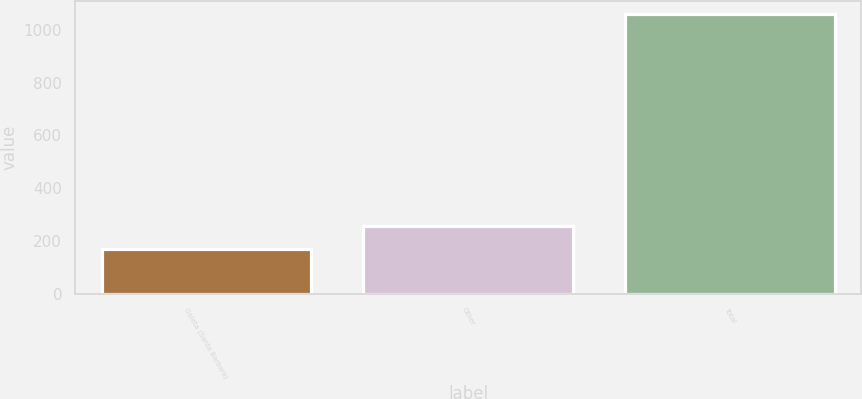Convert chart to OTSL. <chart><loc_0><loc_0><loc_500><loc_500><bar_chart><fcel>Goleta (Santa Barbara)<fcel>Other<fcel>Total<nl><fcel>169<fcel>257.9<fcel>1058<nl></chart> 